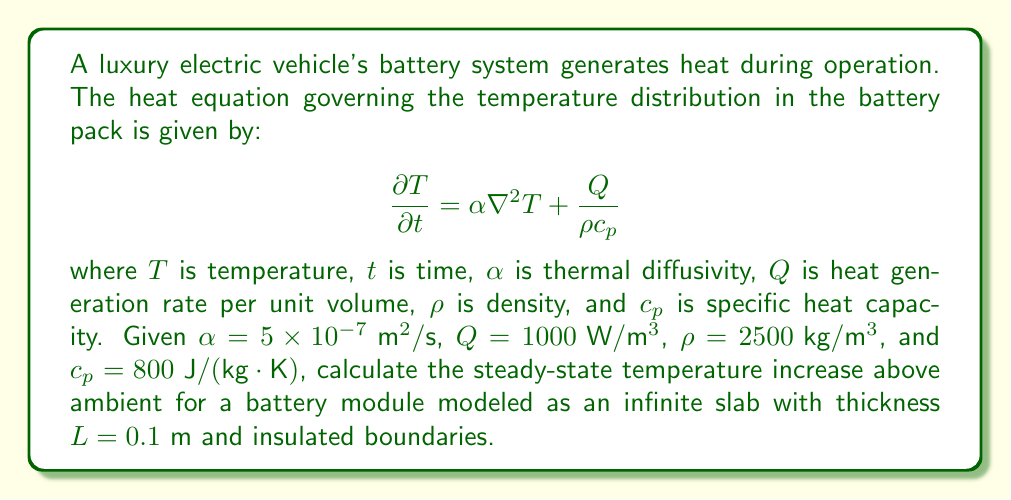Provide a solution to this math problem. To solve this problem, we'll follow these steps:

1) For steady-state conditions, $\frac{\partial T}{\partial t} = 0$, so the heat equation becomes:

   $$0 = \alpha \nabla^2 T + \frac{Q}{\rho c_p}$$

2) For a one-dimensional slab, $\nabla^2 T = \frac{d^2T}{dx^2}$, so:

   $$0 = \alpha \frac{d^2T}{dx^2} + \frac{Q}{\rho c_p}$$

3) Integrate this equation twice:

   $$\frac{dT}{dx} = -\frac{Q}{\alpha \rho c_p}x + C_1$$
   $$T = -\frac{Q}{2\alpha \rho c_p}x^2 + C_1x + C_2$$

4) Apply boundary conditions. For insulated boundaries, $\frac{dT}{dx} = 0$ at $x = 0$ and $x = L$:

   At $x = 0$: $C_1 = 0$
   At $x = L$: $-\frac{Q}{\alpha \rho c_p}L + C_1 = 0$ (satisfied when $C_1 = 0$)

5) The temperature profile is thus:

   $$T = -\frac{Q}{2\alpha \rho c_p}x^2 + C_2$$

6) The maximum temperature increase occurs at the center ($x = L/2$):

   $$\Delta T_{\text{max}} = -\frac{Q}{2\alpha \rho c_p}(\frac{L}{2})^2 = \frac{QL^2}{8\alpha \rho c_p}$$

7) Substitute the given values:

   $$\Delta T_{\text{max}} = \frac{1000 \cdot (0.1)^2}{8 \cdot 5 \times 10^{-7} \cdot 2500 \cdot 800} = 1.25 \text{ K}$$
Answer: 1.25 K 